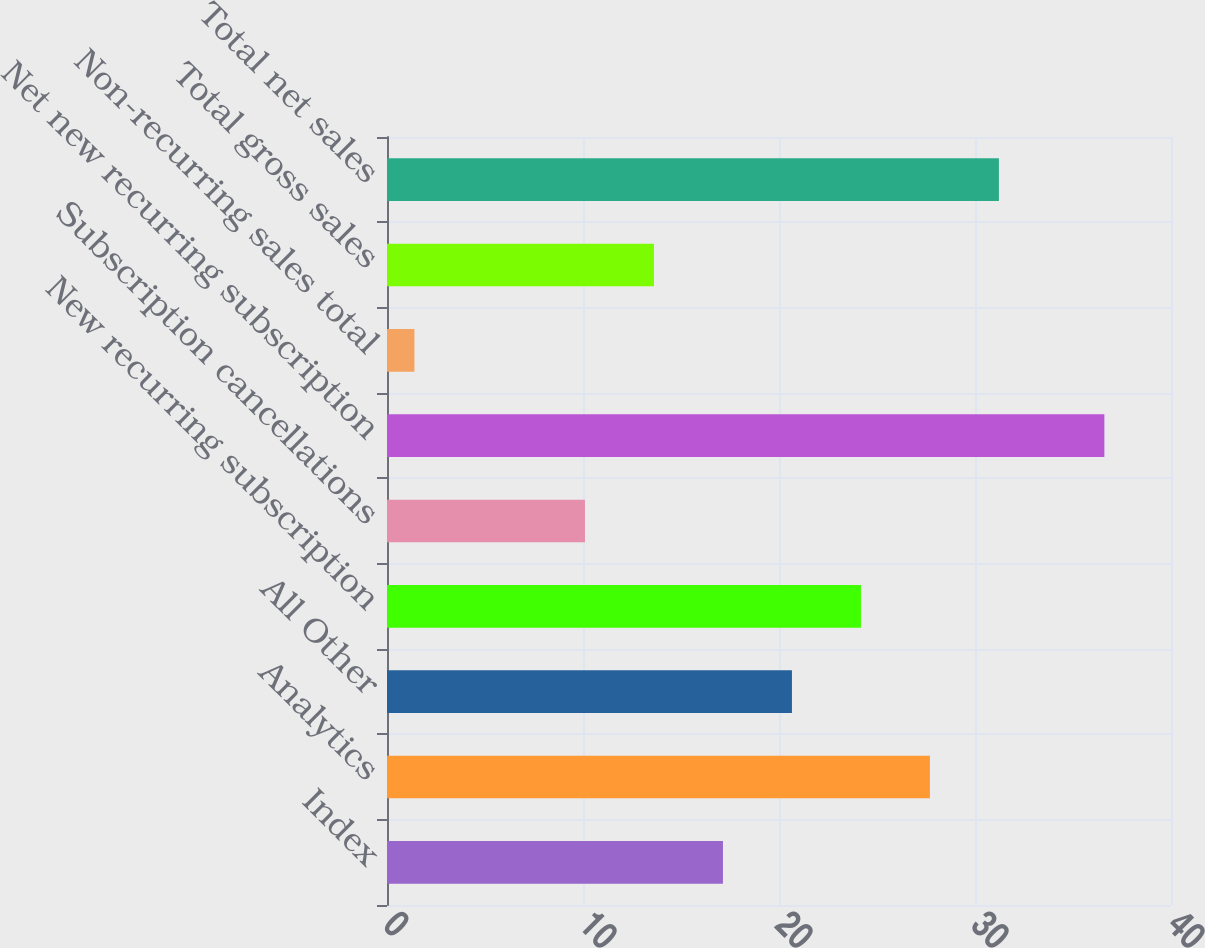Convert chart. <chart><loc_0><loc_0><loc_500><loc_500><bar_chart><fcel>Index<fcel>Analytics<fcel>All Other<fcel>New recurring subscription<fcel>Subscription cancellations<fcel>Net new recurring subscription<fcel>Non-recurring sales total<fcel>Total gross sales<fcel>Total net sales<nl><fcel>17.14<fcel>27.7<fcel>20.66<fcel>24.18<fcel>10.1<fcel>36.6<fcel>1.4<fcel>13.62<fcel>31.22<nl></chart> 